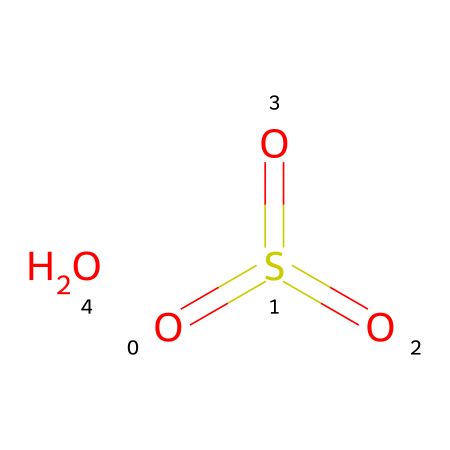What is the molecular formula of this chemical? The SMILES representation indicates sulfur (S) bonded to three oxygen (O) atoms in an arrangement suggesting a sulfate structure. Counting the atoms yields one sulfur and four oxygen atoms, leading to the molecular formula H2S2O4.
Answer: H2S2O4 How many double bonds are present in this structure? Analyzing the SMILES representation shows that sulfur is connected to three oxygen atoms, with two of those connections being double bonds (the symbols “==” denote these). Therefore, there are two double bonds present in the structure.
Answer: 2 What is the expected state of this chemical at room temperature? Given that sulfur trioxide is a well-known compound that is gaseous at room temperature, based on its properties and structure, the expected state is gas.
Answer: gas Which functional group is associated with this chemical? The presence of sulfur and the arrangement of oxygen atoms indicate that this chemical can form an acid when it reacts with water, specifically a sulfonic acid. This is characteristic of acid anhydrides similar to this structure.
Answer: acid anhydride What effect does this chemical have when released into the atmosphere? When sulfur trioxide is released, it reacts with water vapor to form sulfuric acid, contributing significantly to acid rain formation. This change is crucial as it can lead to environmental damage and impacts on ecosystems.
Answer: contributes to acid rain 